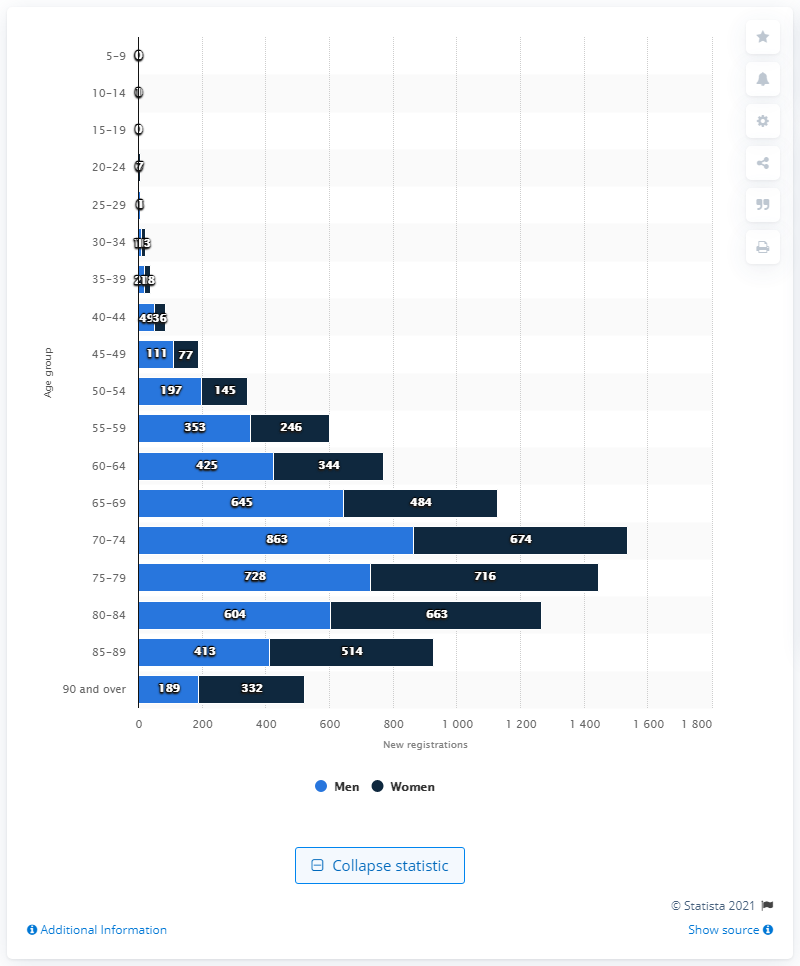Give some essential details in this illustration. In 2018, a total of 863 cases of pancreatic cancer were diagnosed in England. 